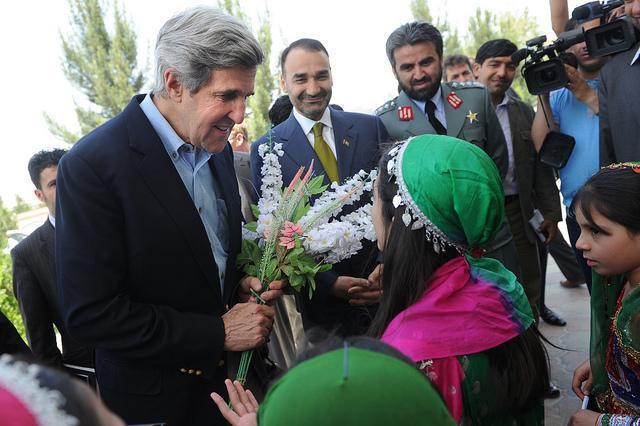How many people are there?
Give a very brief answer. 12. 